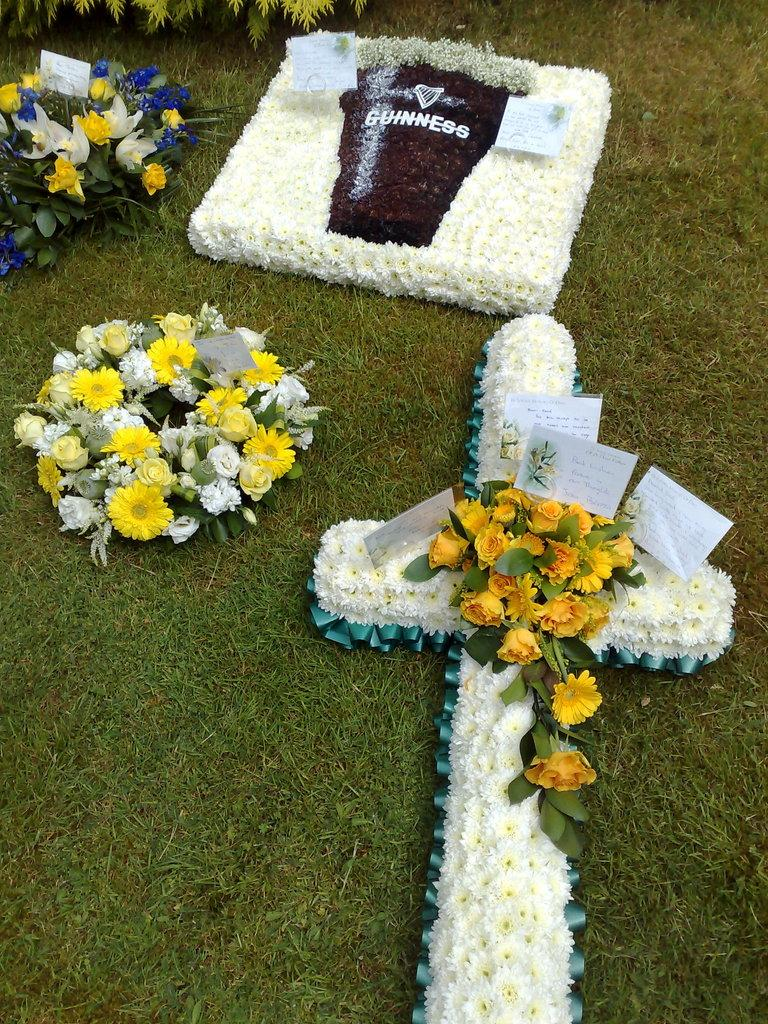What is present in the image that represents flowers? There are bouquets in the image. Where are the bouquets located? The bouquets are placed on grass. What is attached to the bouquets? There are cards on the bouquets. What type of vegetation can be seen at the top of the image? Leaves are visible at the top of the image. What type of pear is being used to write a message on the cards in the image? There is no pear present in the image, and no writing or messages are visible on the cards. 